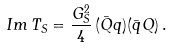<formula> <loc_0><loc_0><loc_500><loc_500>I m \, T _ { S } = \frac { G _ { S } ^ { 2 } } { 4 } \, ( \bar { Q } q ) ( \bar { q } Q ) \, .</formula> 